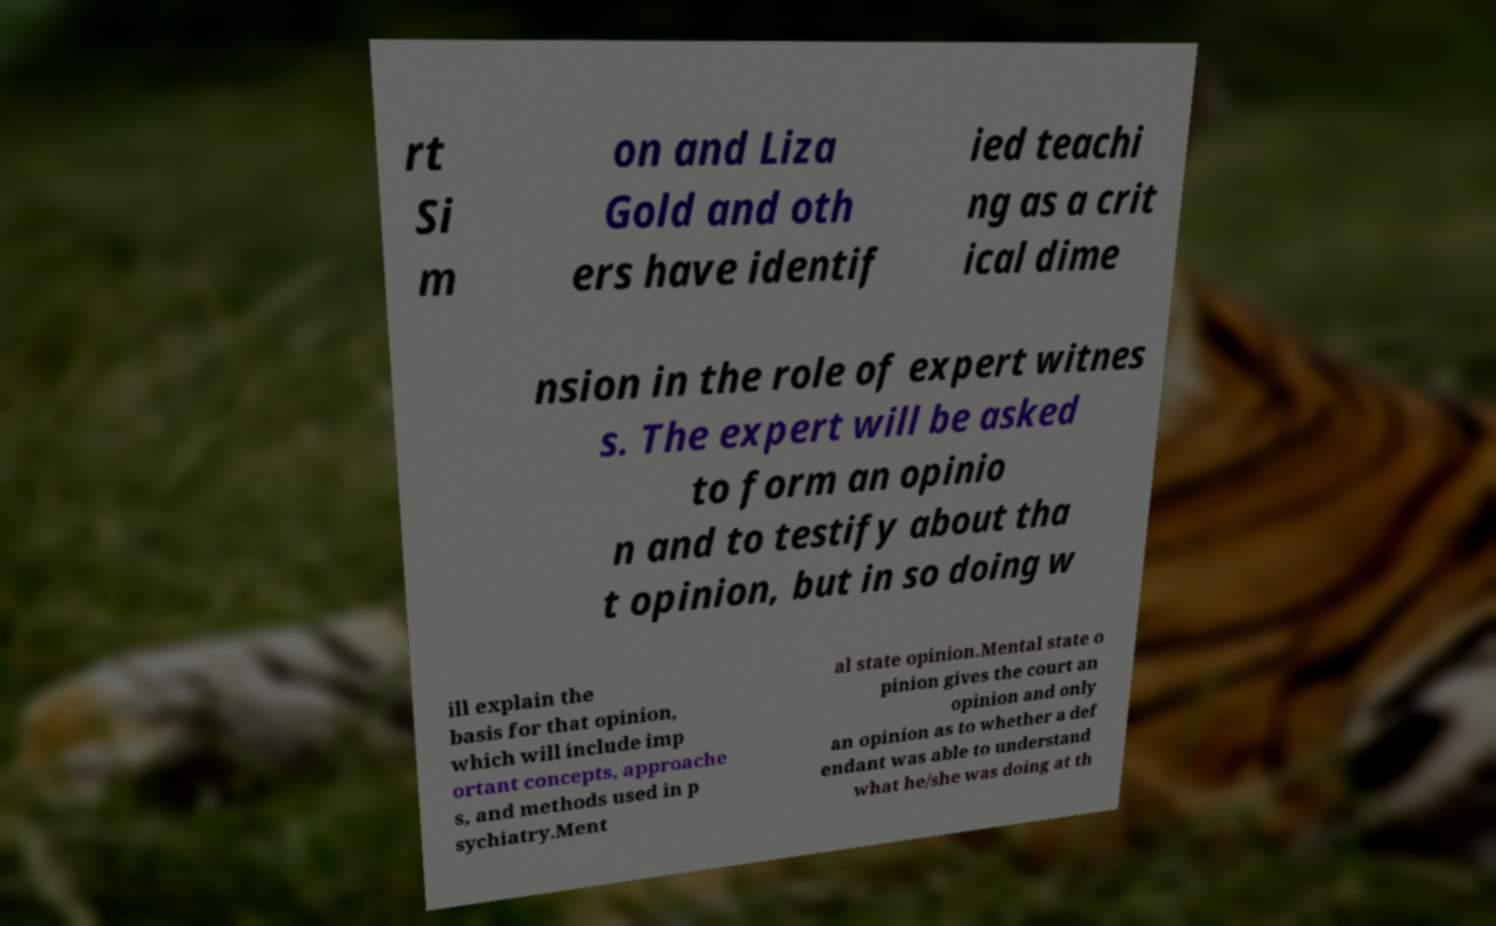For documentation purposes, I need the text within this image transcribed. Could you provide that? rt Si m on and Liza Gold and oth ers have identif ied teachi ng as a crit ical dime nsion in the role of expert witnes s. The expert will be asked to form an opinio n and to testify about tha t opinion, but in so doing w ill explain the basis for that opinion, which will include imp ortant concepts, approache s, and methods used in p sychiatry.Ment al state opinion.Mental state o pinion gives the court an opinion and only an opinion as to whether a def endant was able to understand what he/she was doing at th 